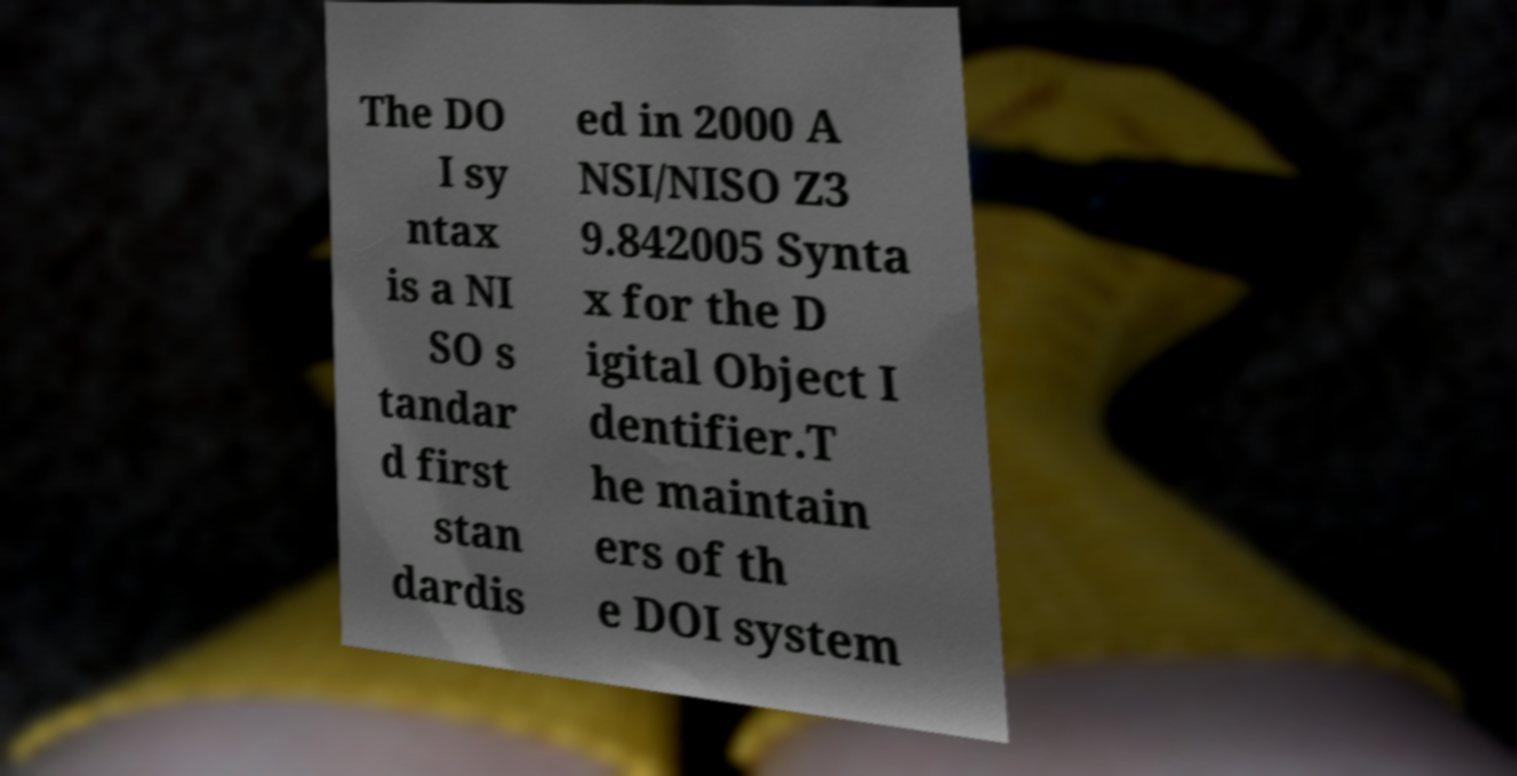Could you extract and type out the text from this image? The DO I sy ntax is a NI SO s tandar d first stan dardis ed in 2000 A NSI/NISO Z3 9.842005 Synta x for the D igital Object I dentifier.T he maintain ers of th e DOI system 